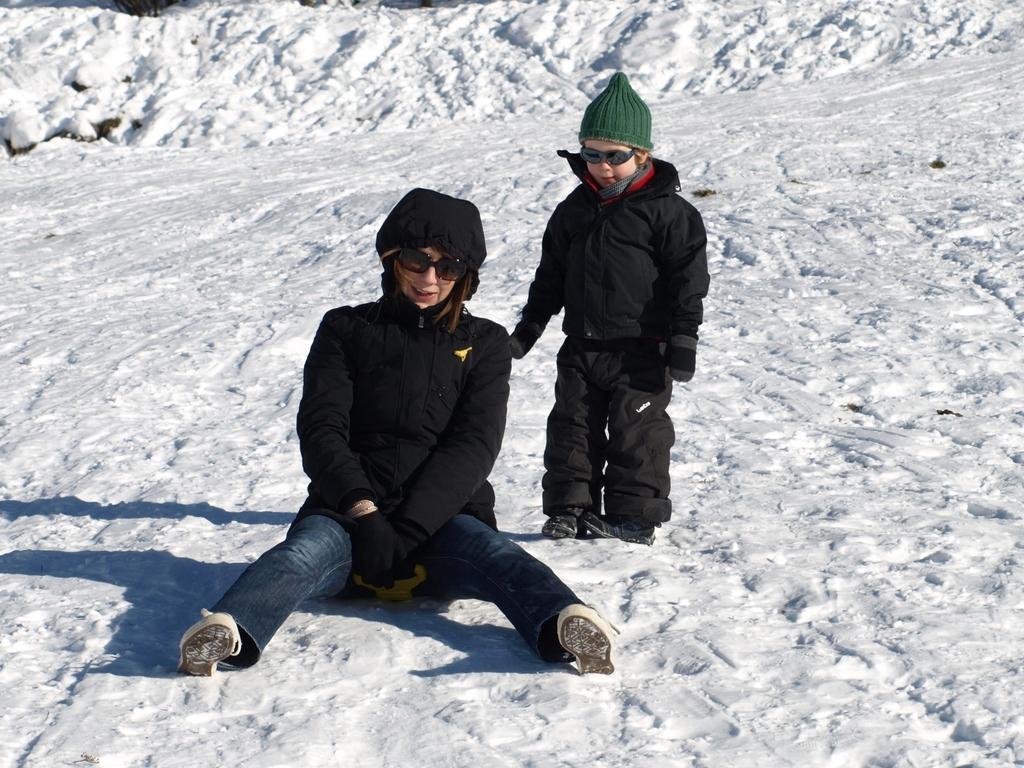Can you describe this image briefly? In this image in the foreground there are two people visible on the snow floor and they both are wearing black color jacket, spectacle, woman sitting on floor, beside her there is a boy standing. 